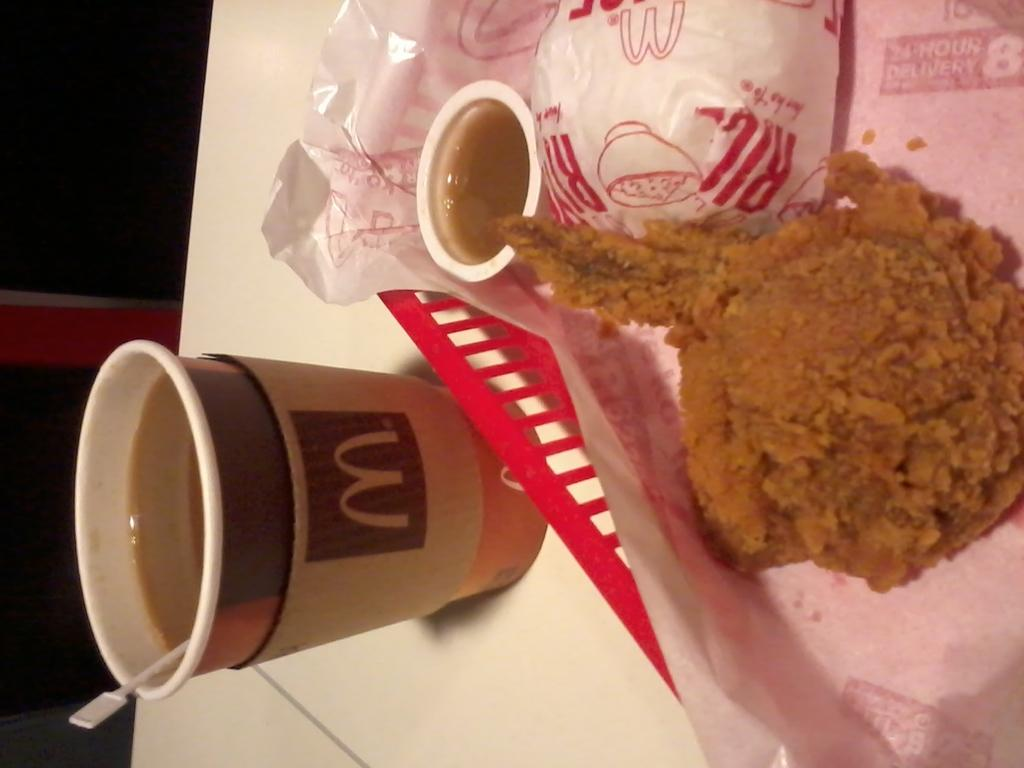What type of animals are present in the image? There are chicken in the image. What objects are visible in the image besides the chicken? There are coffee cups in the image. What is the color of the table at the bottom of the image? The table at the bottom of the image is white. What type of team is playing in the image? There is no team present in the image; it features chicken and coffee cups on a white table. Can you see a hose in the image? There is no hose present in the image. 